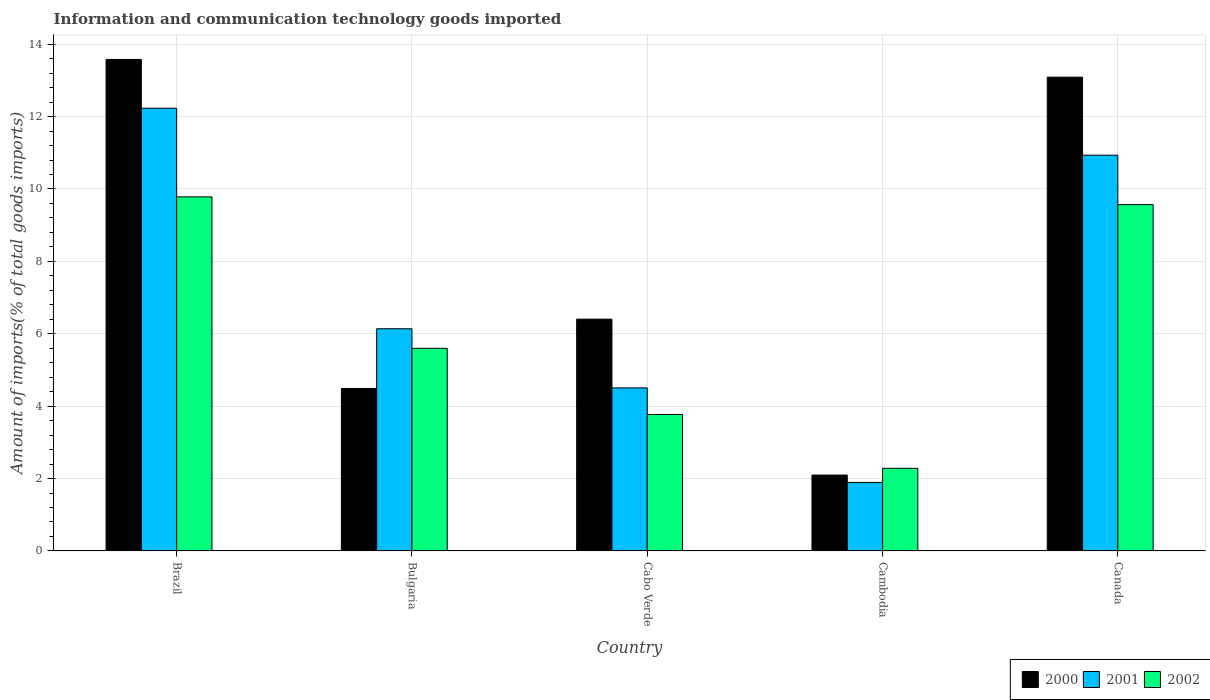Are the number of bars per tick equal to the number of legend labels?
Provide a succinct answer. Yes. Are the number of bars on each tick of the X-axis equal?
Make the answer very short. Yes. How many bars are there on the 4th tick from the right?
Provide a succinct answer. 3. In how many cases, is the number of bars for a given country not equal to the number of legend labels?
Provide a succinct answer. 0. What is the amount of goods imported in 2001 in Cabo Verde?
Provide a short and direct response. 4.5. Across all countries, what is the maximum amount of goods imported in 2002?
Make the answer very short. 9.78. Across all countries, what is the minimum amount of goods imported in 2001?
Provide a succinct answer. 1.89. In which country was the amount of goods imported in 2001 maximum?
Your answer should be very brief. Brazil. In which country was the amount of goods imported in 2002 minimum?
Provide a short and direct response. Cambodia. What is the total amount of goods imported in 2001 in the graph?
Give a very brief answer. 35.7. What is the difference between the amount of goods imported in 2000 in Bulgaria and that in Cabo Verde?
Offer a very short reply. -1.92. What is the difference between the amount of goods imported in 2001 in Cambodia and the amount of goods imported in 2002 in Canada?
Your response must be concise. -7.67. What is the average amount of goods imported in 2001 per country?
Provide a succinct answer. 7.14. What is the difference between the amount of goods imported of/in 2002 and amount of goods imported of/in 2001 in Cambodia?
Offer a terse response. 0.39. In how many countries, is the amount of goods imported in 2002 greater than 6.4 %?
Offer a very short reply. 2. What is the ratio of the amount of goods imported in 2000 in Brazil to that in Bulgaria?
Provide a short and direct response. 3.03. What is the difference between the highest and the second highest amount of goods imported in 2001?
Offer a very short reply. -1.3. What is the difference between the highest and the lowest amount of goods imported in 2002?
Offer a very short reply. 7.5. What does the 3rd bar from the right in Canada represents?
Ensure brevity in your answer.  2000. Does the graph contain grids?
Your response must be concise. Yes. Where does the legend appear in the graph?
Your answer should be compact. Bottom right. How many legend labels are there?
Make the answer very short. 3. What is the title of the graph?
Keep it short and to the point. Information and communication technology goods imported. Does "2002" appear as one of the legend labels in the graph?
Your answer should be very brief. Yes. What is the label or title of the Y-axis?
Make the answer very short. Amount of imports(% of total goods imports). What is the Amount of imports(% of total goods imports) of 2000 in Brazil?
Your answer should be compact. 13.58. What is the Amount of imports(% of total goods imports) of 2001 in Brazil?
Provide a succinct answer. 12.23. What is the Amount of imports(% of total goods imports) of 2002 in Brazil?
Ensure brevity in your answer.  9.78. What is the Amount of imports(% of total goods imports) of 2000 in Bulgaria?
Ensure brevity in your answer.  4.49. What is the Amount of imports(% of total goods imports) of 2001 in Bulgaria?
Ensure brevity in your answer.  6.14. What is the Amount of imports(% of total goods imports) of 2002 in Bulgaria?
Provide a succinct answer. 5.6. What is the Amount of imports(% of total goods imports) of 2000 in Cabo Verde?
Your answer should be very brief. 6.4. What is the Amount of imports(% of total goods imports) of 2001 in Cabo Verde?
Keep it short and to the point. 4.5. What is the Amount of imports(% of total goods imports) of 2002 in Cabo Verde?
Your response must be concise. 3.77. What is the Amount of imports(% of total goods imports) of 2000 in Cambodia?
Provide a short and direct response. 2.1. What is the Amount of imports(% of total goods imports) in 2001 in Cambodia?
Ensure brevity in your answer.  1.89. What is the Amount of imports(% of total goods imports) of 2002 in Cambodia?
Give a very brief answer. 2.28. What is the Amount of imports(% of total goods imports) in 2000 in Canada?
Make the answer very short. 13.09. What is the Amount of imports(% of total goods imports) of 2001 in Canada?
Keep it short and to the point. 10.93. What is the Amount of imports(% of total goods imports) in 2002 in Canada?
Keep it short and to the point. 9.57. Across all countries, what is the maximum Amount of imports(% of total goods imports) in 2000?
Offer a very short reply. 13.58. Across all countries, what is the maximum Amount of imports(% of total goods imports) of 2001?
Offer a terse response. 12.23. Across all countries, what is the maximum Amount of imports(% of total goods imports) of 2002?
Provide a succinct answer. 9.78. Across all countries, what is the minimum Amount of imports(% of total goods imports) of 2000?
Your answer should be very brief. 2.1. Across all countries, what is the minimum Amount of imports(% of total goods imports) in 2001?
Your answer should be very brief. 1.89. Across all countries, what is the minimum Amount of imports(% of total goods imports) of 2002?
Offer a very short reply. 2.28. What is the total Amount of imports(% of total goods imports) of 2000 in the graph?
Give a very brief answer. 39.65. What is the total Amount of imports(% of total goods imports) in 2001 in the graph?
Provide a short and direct response. 35.7. What is the total Amount of imports(% of total goods imports) in 2002 in the graph?
Your answer should be compact. 31. What is the difference between the Amount of imports(% of total goods imports) in 2000 in Brazil and that in Bulgaria?
Ensure brevity in your answer.  9.09. What is the difference between the Amount of imports(% of total goods imports) in 2001 in Brazil and that in Bulgaria?
Make the answer very short. 6.09. What is the difference between the Amount of imports(% of total goods imports) in 2002 in Brazil and that in Bulgaria?
Offer a very short reply. 4.18. What is the difference between the Amount of imports(% of total goods imports) of 2000 in Brazil and that in Cabo Verde?
Offer a terse response. 7.17. What is the difference between the Amount of imports(% of total goods imports) in 2001 in Brazil and that in Cabo Verde?
Provide a succinct answer. 7.73. What is the difference between the Amount of imports(% of total goods imports) in 2002 in Brazil and that in Cabo Verde?
Your answer should be compact. 6.01. What is the difference between the Amount of imports(% of total goods imports) in 2000 in Brazil and that in Cambodia?
Provide a short and direct response. 11.48. What is the difference between the Amount of imports(% of total goods imports) of 2001 in Brazil and that in Cambodia?
Keep it short and to the point. 10.34. What is the difference between the Amount of imports(% of total goods imports) in 2002 in Brazil and that in Cambodia?
Your answer should be compact. 7.5. What is the difference between the Amount of imports(% of total goods imports) in 2000 in Brazil and that in Canada?
Your answer should be compact. 0.49. What is the difference between the Amount of imports(% of total goods imports) of 2001 in Brazil and that in Canada?
Make the answer very short. 1.3. What is the difference between the Amount of imports(% of total goods imports) in 2002 in Brazil and that in Canada?
Provide a succinct answer. 0.21. What is the difference between the Amount of imports(% of total goods imports) of 2000 in Bulgaria and that in Cabo Verde?
Provide a succinct answer. -1.92. What is the difference between the Amount of imports(% of total goods imports) of 2001 in Bulgaria and that in Cabo Verde?
Your answer should be compact. 1.63. What is the difference between the Amount of imports(% of total goods imports) of 2002 in Bulgaria and that in Cabo Verde?
Provide a succinct answer. 1.83. What is the difference between the Amount of imports(% of total goods imports) in 2000 in Bulgaria and that in Cambodia?
Ensure brevity in your answer.  2.39. What is the difference between the Amount of imports(% of total goods imports) of 2001 in Bulgaria and that in Cambodia?
Ensure brevity in your answer.  4.25. What is the difference between the Amount of imports(% of total goods imports) in 2002 in Bulgaria and that in Cambodia?
Give a very brief answer. 3.31. What is the difference between the Amount of imports(% of total goods imports) of 2000 in Bulgaria and that in Canada?
Keep it short and to the point. -8.6. What is the difference between the Amount of imports(% of total goods imports) in 2001 in Bulgaria and that in Canada?
Your answer should be compact. -4.79. What is the difference between the Amount of imports(% of total goods imports) of 2002 in Bulgaria and that in Canada?
Offer a terse response. -3.97. What is the difference between the Amount of imports(% of total goods imports) of 2000 in Cabo Verde and that in Cambodia?
Provide a short and direct response. 4.31. What is the difference between the Amount of imports(% of total goods imports) in 2001 in Cabo Verde and that in Cambodia?
Give a very brief answer. 2.61. What is the difference between the Amount of imports(% of total goods imports) of 2002 in Cabo Verde and that in Cambodia?
Offer a very short reply. 1.49. What is the difference between the Amount of imports(% of total goods imports) in 2000 in Cabo Verde and that in Canada?
Offer a terse response. -6.68. What is the difference between the Amount of imports(% of total goods imports) of 2001 in Cabo Verde and that in Canada?
Make the answer very short. -6.43. What is the difference between the Amount of imports(% of total goods imports) of 2002 in Cabo Verde and that in Canada?
Ensure brevity in your answer.  -5.8. What is the difference between the Amount of imports(% of total goods imports) in 2000 in Cambodia and that in Canada?
Make the answer very short. -10.99. What is the difference between the Amount of imports(% of total goods imports) in 2001 in Cambodia and that in Canada?
Give a very brief answer. -9.04. What is the difference between the Amount of imports(% of total goods imports) in 2002 in Cambodia and that in Canada?
Give a very brief answer. -7.28. What is the difference between the Amount of imports(% of total goods imports) of 2000 in Brazil and the Amount of imports(% of total goods imports) of 2001 in Bulgaria?
Ensure brevity in your answer.  7.44. What is the difference between the Amount of imports(% of total goods imports) of 2000 in Brazil and the Amount of imports(% of total goods imports) of 2002 in Bulgaria?
Keep it short and to the point. 7.98. What is the difference between the Amount of imports(% of total goods imports) of 2001 in Brazil and the Amount of imports(% of total goods imports) of 2002 in Bulgaria?
Make the answer very short. 6.63. What is the difference between the Amount of imports(% of total goods imports) of 2000 in Brazil and the Amount of imports(% of total goods imports) of 2001 in Cabo Verde?
Offer a terse response. 9.07. What is the difference between the Amount of imports(% of total goods imports) of 2000 in Brazil and the Amount of imports(% of total goods imports) of 2002 in Cabo Verde?
Offer a terse response. 9.81. What is the difference between the Amount of imports(% of total goods imports) of 2001 in Brazil and the Amount of imports(% of total goods imports) of 2002 in Cabo Verde?
Provide a short and direct response. 8.46. What is the difference between the Amount of imports(% of total goods imports) in 2000 in Brazil and the Amount of imports(% of total goods imports) in 2001 in Cambodia?
Your response must be concise. 11.69. What is the difference between the Amount of imports(% of total goods imports) of 2000 in Brazil and the Amount of imports(% of total goods imports) of 2002 in Cambodia?
Ensure brevity in your answer.  11.3. What is the difference between the Amount of imports(% of total goods imports) in 2001 in Brazil and the Amount of imports(% of total goods imports) in 2002 in Cambodia?
Offer a terse response. 9.95. What is the difference between the Amount of imports(% of total goods imports) in 2000 in Brazil and the Amount of imports(% of total goods imports) in 2001 in Canada?
Your answer should be very brief. 2.65. What is the difference between the Amount of imports(% of total goods imports) of 2000 in Brazil and the Amount of imports(% of total goods imports) of 2002 in Canada?
Your answer should be very brief. 4.01. What is the difference between the Amount of imports(% of total goods imports) in 2001 in Brazil and the Amount of imports(% of total goods imports) in 2002 in Canada?
Give a very brief answer. 2.66. What is the difference between the Amount of imports(% of total goods imports) in 2000 in Bulgaria and the Amount of imports(% of total goods imports) in 2001 in Cabo Verde?
Offer a terse response. -0.02. What is the difference between the Amount of imports(% of total goods imports) of 2000 in Bulgaria and the Amount of imports(% of total goods imports) of 2002 in Cabo Verde?
Your answer should be compact. 0.72. What is the difference between the Amount of imports(% of total goods imports) in 2001 in Bulgaria and the Amount of imports(% of total goods imports) in 2002 in Cabo Verde?
Provide a short and direct response. 2.37. What is the difference between the Amount of imports(% of total goods imports) of 2000 in Bulgaria and the Amount of imports(% of total goods imports) of 2001 in Cambodia?
Your answer should be compact. 2.6. What is the difference between the Amount of imports(% of total goods imports) of 2000 in Bulgaria and the Amount of imports(% of total goods imports) of 2002 in Cambodia?
Your answer should be compact. 2.21. What is the difference between the Amount of imports(% of total goods imports) in 2001 in Bulgaria and the Amount of imports(% of total goods imports) in 2002 in Cambodia?
Your answer should be very brief. 3.86. What is the difference between the Amount of imports(% of total goods imports) of 2000 in Bulgaria and the Amount of imports(% of total goods imports) of 2001 in Canada?
Keep it short and to the point. -6.44. What is the difference between the Amount of imports(% of total goods imports) in 2000 in Bulgaria and the Amount of imports(% of total goods imports) in 2002 in Canada?
Your answer should be compact. -5.08. What is the difference between the Amount of imports(% of total goods imports) in 2001 in Bulgaria and the Amount of imports(% of total goods imports) in 2002 in Canada?
Give a very brief answer. -3.43. What is the difference between the Amount of imports(% of total goods imports) of 2000 in Cabo Verde and the Amount of imports(% of total goods imports) of 2001 in Cambodia?
Your answer should be very brief. 4.51. What is the difference between the Amount of imports(% of total goods imports) of 2000 in Cabo Verde and the Amount of imports(% of total goods imports) of 2002 in Cambodia?
Your answer should be very brief. 4.12. What is the difference between the Amount of imports(% of total goods imports) of 2001 in Cabo Verde and the Amount of imports(% of total goods imports) of 2002 in Cambodia?
Keep it short and to the point. 2.22. What is the difference between the Amount of imports(% of total goods imports) in 2000 in Cabo Verde and the Amount of imports(% of total goods imports) in 2001 in Canada?
Provide a succinct answer. -4.53. What is the difference between the Amount of imports(% of total goods imports) in 2000 in Cabo Verde and the Amount of imports(% of total goods imports) in 2002 in Canada?
Offer a terse response. -3.16. What is the difference between the Amount of imports(% of total goods imports) in 2001 in Cabo Verde and the Amount of imports(% of total goods imports) in 2002 in Canada?
Offer a terse response. -5.06. What is the difference between the Amount of imports(% of total goods imports) in 2000 in Cambodia and the Amount of imports(% of total goods imports) in 2001 in Canada?
Your answer should be compact. -8.84. What is the difference between the Amount of imports(% of total goods imports) in 2000 in Cambodia and the Amount of imports(% of total goods imports) in 2002 in Canada?
Give a very brief answer. -7.47. What is the difference between the Amount of imports(% of total goods imports) of 2001 in Cambodia and the Amount of imports(% of total goods imports) of 2002 in Canada?
Offer a very short reply. -7.67. What is the average Amount of imports(% of total goods imports) of 2000 per country?
Provide a succinct answer. 7.93. What is the average Amount of imports(% of total goods imports) in 2001 per country?
Ensure brevity in your answer.  7.14. What is the average Amount of imports(% of total goods imports) of 2002 per country?
Your response must be concise. 6.2. What is the difference between the Amount of imports(% of total goods imports) in 2000 and Amount of imports(% of total goods imports) in 2001 in Brazil?
Offer a very short reply. 1.35. What is the difference between the Amount of imports(% of total goods imports) in 2000 and Amount of imports(% of total goods imports) in 2002 in Brazil?
Your answer should be very brief. 3.8. What is the difference between the Amount of imports(% of total goods imports) in 2001 and Amount of imports(% of total goods imports) in 2002 in Brazil?
Provide a succinct answer. 2.45. What is the difference between the Amount of imports(% of total goods imports) of 2000 and Amount of imports(% of total goods imports) of 2001 in Bulgaria?
Make the answer very short. -1.65. What is the difference between the Amount of imports(% of total goods imports) in 2000 and Amount of imports(% of total goods imports) in 2002 in Bulgaria?
Offer a terse response. -1.11. What is the difference between the Amount of imports(% of total goods imports) in 2001 and Amount of imports(% of total goods imports) in 2002 in Bulgaria?
Your answer should be very brief. 0.54. What is the difference between the Amount of imports(% of total goods imports) of 2000 and Amount of imports(% of total goods imports) of 2001 in Cabo Verde?
Provide a succinct answer. 1.9. What is the difference between the Amount of imports(% of total goods imports) in 2000 and Amount of imports(% of total goods imports) in 2002 in Cabo Verde?
Offer a terse response. 2.63. What is the difference between the Amount of imports(% of total goods imports) in 2001 and Amount of imports(% of total goods imports) in 2002 in Cabo Verde?
Your response must be concise. 0.73. What is the difference between the Amount of imports(% of total goods imports) of 2000 and Amount of imports(% of total goods imports) of 2001 in Cambodia?
Give a very brief answer. 0.2. What is the difference between the Amount of imports(% of total goods imports) in 2000 and Amount of imports(% of total goods imports) in 2002 in Cambodia?
Provide a short and direct response. -0.19. What is the difference between the Amount of imports(% of total goods imports) in 2001 and Amount of imports(% of total goods imports) in 2002 in Cambodia?
Provide a short and direct response. -0.39. What is the difference between the Amount of imports(% of total goods imports) in 2000 and Amount of imports(% of total goods imports) in 2001 in Canada?
Give a very brief answer. 2.16. What is the difference between the Amount of imports(% of total goods imports) of 2000 and Amount of imports(% of total goods imports) of 2002 in Canada?
Offer a very short reply. 3.52. What is the difference between the Amount of imports(% of total goods imports) in 2001 and Amount of imports(% of total goods imports) in 2002 in Canada?
Give a very brief answer. 1.37. What is the ratio of the Amount of imports(% of total goods imports) of 2000 in Brazil to that in Bulgaria?
Your answer should be compact. 3.03. What is the ratio of the Amount of imports(% of total goods imports) in 2001 in Brazil to that in Bulgaria?
Make the answer very short. 1.99. What is the ratio of the Amount of imports(% of total goods imports) in 2002 in Brazil to that in Bulgaria?
Your answer should be compact. 1.75. What is the ratio of the Amount of imports(% of total goods imports) in 2000 in Brazil to that in Cabo Verde?
Your answer should be very brief. 2.12. What is the ratio of the Amount of imports(% of total goods imports) of 2001 in Brazil to that in Cabo Verde?
Your answer should be compact. 2.72. What is the ratio of the Amount of imports(% of total goods imports) in 2002 in Brazil to that in Cabo Verde?
Ensure brevity in your answer.  2.59. What is the ratio of the Amount of imports(% of total goods imports) in 2000 in Brazil to that in Cambodia?
Offer a terse response. 6.48. What is the ratio of the Amount of imports(% of total goods imports) of 2001 in Brazil to that in Cambodia?
Provide a short and direct response. 6.46. What is the ratio of the Amount of imports(% of total goods imports) of 2002 in Brazil to that in Cambodia?
Your response must be concise. 4.29. What is the ratio of the Amount of imports(% of total goods imports) in 2000 in Brazil to that in Canada?
Provide a succinct answer. 1.04. What is the ratio of the Amount of imports(% of total goods imports) in 2001 in Brazil to that in Canada?
Your answer should be compact. 1.12. What is the ratio of the Amount of imports(% of total goods imports) of 2002 in Brazil to that in Canada?
Offer a terse response. 1.02. What is the ratio of the Amount of imports(% of total goods imports) of 2000 in Bulgaria to that in Cabo Verde?
Give a very brief answer. 0.7. What is the ratio of the Amount of imports(% of total goods imports) of 2001 in Bulgaria to that in Cabo Verde?
Provide a short and direct response. 1.36. What is the ratio of the Amount of imports(% of total goods imports) of 2002 in Bulgaria to that in Cabo Verde?
Offer a very short reply. 1.48. What is the ratio of the Amount of imports(% of total goods imports) in 2000 in Bulgaria to that in Cambodia?
Offer a terse response. 2.14. What is the ratio of the Amount of imports(% of total goods imports) of 2001 in Bulgaria to that in Cambodia?
Provide a short and direct response. 3.24. What is the ratio of the Amount of imports(% of total goods imports) of 2002 in Bulgaria to that in Cambodia?
Make the answer very short. 2.45. What is the ratio of the Amount of imports(% of total goods imports) of 2000 in Bulgaria to that in Canada?
Provide a short and direct response. 0.34. What is the ratio of the Amount of imports(% of total goods imports) of 2001 in Bulgaria to that in Canada?
Your answer should be very brief. 0.56. What is the ratio of the Amount of imports(% of total goods imports) in 2002 in Bulgaria to that in Canada?
Your answer should be very brief. 0.59. What is the ratio of the Amount of imports(% of total goods imports) in 2000 in Cabo Verde to that in Cambodia?
Offer a very short reply. 3.05. What is the ratio of the Amount of imports(% of total goods imports) of 2001 in Cabo Verde to that in Cambodia?
Your answer should be very brief. 2.38. What is the ratio of the Amount of imports(% of total goods imports) in 2002 in Cabo Verde to that in Cambodia?
Offer a terse response. 1.65. What is the ratio of the Amount of imports(% of total goods imports) of 2000 in Cabo Verde to that in Canada?
Your answer should be compact. 0.49. What is the ratio of the Amount of imports(% of total goods imports) of 2001 in Cabo Verde to that in Canada?
Ensure brevity in your answer.  0.41. What is the ratio of the Amount of imports(% of total goods imports) of 2002 in Cabo Verde to that in Canada?
Make the answer very short. 0.39. What is the ratio of the Amount of imports(% of total goods imports) in 2000 in Cambodia to that in Canada?
Offer a terse response. 0.16. What is the ratio of the Amount of imports(% of total goods imports) in 2001 in Cambodia to that in Canada?
Your answer should be compact. 0.17. What is the ratio of the Amount of imports(% of total goods imports) of 2002 in Cambodia to that in Canada?
Your response must be concise. 0.24. What is the difference between the highest and the second highest Amount of imports(% of total goods imports) in 2000?
Make the answer very short. 0.49. What is the difference between the highest and the second highest Amount of imports(% of total goods imports) of 2001?
Provide a succinct answer. 1.3. What is the difference between the highest and the second highest Amount of imports(% of total goods imports) of 2002?
Provide a succinct answer. 0.21. What is the difference between the highest and the lowest Amount of imports(% of total goods imports) in 2000?
Make the answer very short. 11.48. What is the difference between the highest and the lowest Amount of imports(% of total goods imports) of 2001?
Ensure brevity in your answer.  10.34. What is the difference between the highest and the lowest Amount of imports(% of total goods imports) in 2002?
Your answer should be very brief. 7.5. 